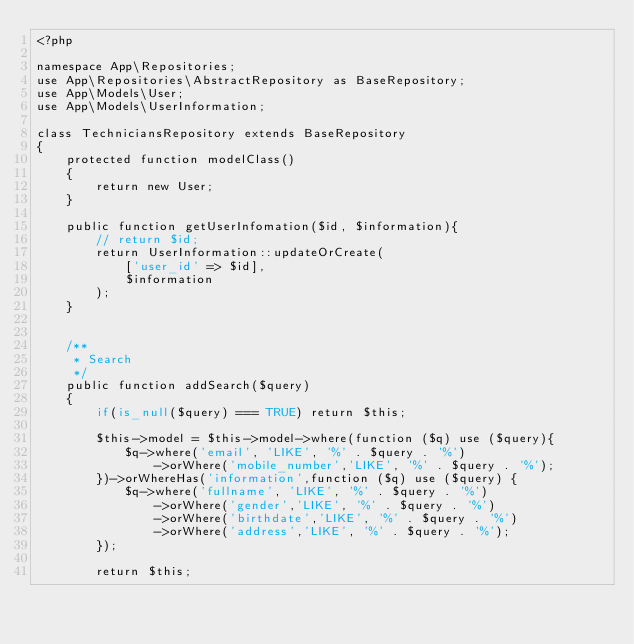<code> <loc_0><loc_0><loc_500><loc_500><_PHP_><?php

namespace App\Repositories;
use App\Repositories\AbstractRepository as BaseRepository;
use App\Models\User;
use App\Models\UserInformation;

class TechniciansRepository extends BaseRepository
{
    protected function modelClass()
    {
        return new User;
    }

    public function getUserInfomation($id, $information){
        // return $id;
        return UserInformation::updateOrCreate(
            ['user_id' => $id],
            $information
        );
    }


    /**
     * Search
     */
    public function addSearch($query)
    {
        if(is_null($query) === TRUE) return $this;

        $this->model = $this->model->where(function ($q) use ($query){
            $q->where('email', 'LIKE', '%' . $query . '%')
                ->orWhere('mobile_number','LIKE', '%' . $query . '%');
        })->orWhereHas('information',function ($q) use ($query) {
            $q->where('fullname', 'LIKE', '%' . $query . '%')
                ->orWhere('gender','LIKE', '%' . $query . '%')
                ->orWhere('birthdate','LIKE', '%' . $query . '%')
                ->orWhere('address','LIKE', '%' . $query . '%');
        });

        return $this;</code> 